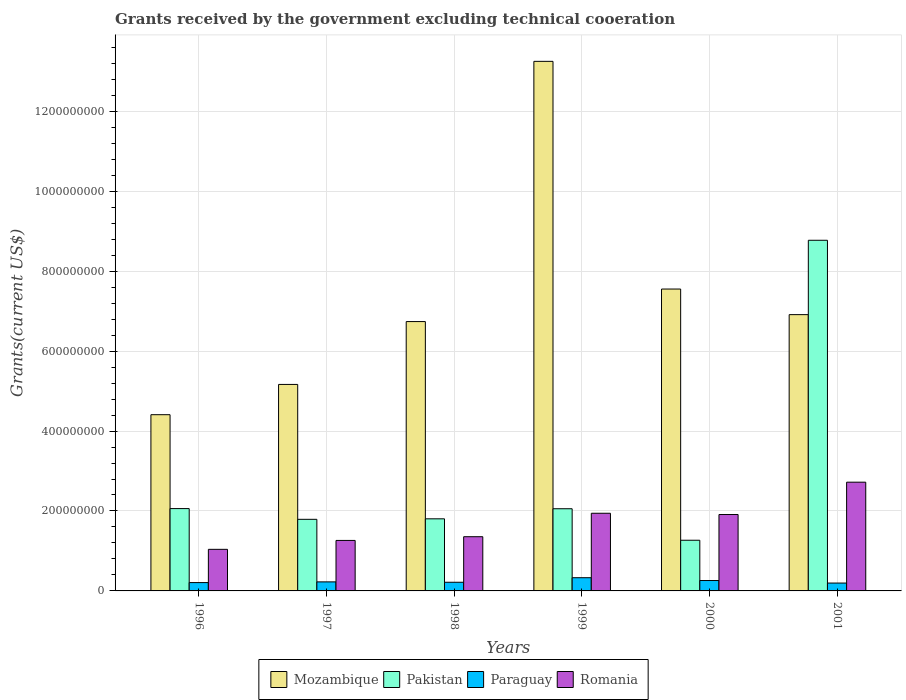How many groups of bars are there?
Provide a short and direct response. 6. How many bars are there on the 3rd tick from the left?
Give a very brief answer. 4. How many bars are there on the 3rd tick from the right?
Make the answer very short. 4. What is the total grants received by the government in Paraguay in 2001?
Offer a very short reply. 1.97e+07. Across all years, what is the maximum total grants received by the government in Mozambique?
Your answer should be very brief. 1.32e+09. Across all years, what is the minimum total grants received by the government in Pakistan?
Make the answer very short. 1.27e+08. In which year was the total grants received by the government in Mozambique minimum?
Your answer should be very brief. 1996. What is the total total grants received by the government in Mozambique in the graph?
Keep it short and to the point. 4.40e+09. What is the difference between the total grants received by the government in Mozambique in 1997 and that in 2001?
Offer a very short reply. -1.75e+08. What is the difference between the total grants received by the government in Paraguay in 2000 and the total grants received by the government in Pakistan in 2001?
Offer a terse response. -8.51e+08. What is the average total grants received by the government in Mozambique per year?
Provide a succinct answer. 7.34e+08. In the year 1998, what is the difference between the total grants received by the government in Romania and total grants received by the government in Mozambique?
Your answer should be compact. -5.38e+08. In how many years, is the total grants received by the government in Pakistan greater than 800000000 US$?
Provide a succinct answer. 1. What is the ratio of the total grants received by the government in Paraguay in 1996 to that in 1999?
Offer a terse response. 0.63. Is the total grants received by the government in Romania in 1997 less than that in 2000?
Provide a short and direct response. Yes. Is the difference between the total grants received by the government in Romania in 1996 and 1998 greater than the difference between the total grants received by the government in Mozambique in 1996 and 1998?
Provide a short and direct response. Yes. What is the difference between the highest and the second highest total grants received by the government in Mozambique?
Ensure brevity in your answer.  5.70e+08. What is the difference between the highest and the lowest total grants received by the government in Mozambique?
Offer a very short reply. 8.84e+08. Is it the case that in every year, the sum of the total grants received by the government in Pakistan and total grants received by the government in Mozambique is greater than the sum of total grants received by the government in Paraguay and total grants received by the government in Romania?
Make the answer very short. No. What does the 3rd bar from the left in 1999 represents?
Ensure brevity in your answer.  Paraguay. What does the 3rd bar from the right in 2000 represents?
Keep it short and to the point. Pakistan. Are all the bars in the graph horizontal?
Provide a short and direct response. No. Does the graph contain any zero values?
Give a very brief answer. No. Does the graph contain grids?
Provide a succinct answer. Yes. Where does the legend appear in the graph?
Your answer should be very brief. Bottom center. What is the title of the graph?
Your answer should be compact. Grants received by the government excluding technical cooeration. Does "Korea (Republic)" appear as one of the legend labels in the graph?
Your answer should be very brief. No. What is the label or title of the Y-axis?
Offer a very short reply. Grants(current US$). What is the Grants(current US$) in Mozambique in 1996?
Make the answer very short. 4.41e+08. What is the Grants(current US$) of Pakistan in 1996?
Give a very brief answer. 2.06e+08. What is the Grants(current US$) of Paraguay in 1996?
Keep it short and to the point. 2.08e+07. What is the Grants(current US$) in Romania in 1996?
Give a very brief answer. 1.04e+08. What is the Grants(current US$) of Mozambique in 1997?
Keep it short and to the point. 5.17e+08. What is the Grants(current US$) of Pakistan in 1997?
Provide a succinct answer. 1.79e+08. What is the Grants(current US$) of Paraguay in 1997?
Make the answer very short. 2.26e+07. What is the Grants(current US$) in Romania in 1997?
Provide a short and direct response. 1.26e+08. What is the Grants(current US$) of Mozambique in 1998?
Keep it short and to the point. 6.74e+08. What is the Grants(current US$) in Pakistan in 1998?
Provide a short and direct response. 1.80e+08. What is the Grants(current US$) in Paraguay in 1998?
Offer a terse response. 2.17e+07. What is the Grants(current US$) in Romania in 1998?
Provide a short and direct response. 1.36e+08. What is the Grants(current US$) of Mozambique in 1999?
Your answer should be very brief. 1.32e+09. What is the Grants(current US$) in Pakistan in 1999?
Provide a short and direct response. 2.06e+08. What is the Grants(current US$) of Paraguay in 1999?
Your response must be concise. 3.30e+07. What is the Grants(current US$) of Romania in 1999?
Give a very brief answer. 1.94e+08. What is the Grants(current US$) in Mozambique in 2000?
Keep it short and to the point. 7.55e+08. What is the Grants(current US$) of Pakistan in 2000?
Your answer should be compact. 1.27e+08. What is the Grants(current US$) of Paraguay in 2000?
Provide a short and direct response. 2.60e+07. What is the Grants(current US$) of Romania in 2000?
Your answer should be very brief. 1.91e+08. What is the Grants(current US$) of Mozambique in 2001?
Ensure brevity in your answer.  6.91e+08. What is the Grants(current US$) in Pakistan in 2001?
Offer a very short reply. 8.77e+08. What is the Grants(current US$) of Paraguay in 2001?
Give a very brief answer. 1.97e+07. What is the Grants(current US$) in Romania in 2001?
Give a very brief answer. 2.72e+08. Across all years, what is the maximum Grants(current US$) in Mozambique?
Your response must be concise. 1.32e+09. Across all years, what is the maximum Grants(current US$) of Pakistan?
Your answer should be compact. 8.77e+08. Across all years, what is the maximum Grants(current US$) in Paraguay?
Offer a terse response. 3.30e+07. Across all years, what is the maximum Grants(current US$) in Romania?
Your answer should be compact. 2.72e+08. Across all years, what is the minimum Grants(current US$) of Mozambique?
Provide a short and direct response. 4.41e+08. Across all years, what is the minimum Grants(current US$) in Pakistan?
Offer a very short reply. 1.27e+08. Across all years, what is the minimum Grants(current US$) in Paraguay?
Provide a succinct answer. 1.97e+07. Across all years, what is the minimum Grants(current US$) in Romania?
Make the answer very short. 1.04e+08. What is the total Grants(current US$) of Mozambique in the graph?
Your answer should be very brief. 4.40e+09. What is the total Grants(current US$) in Pakistan in the graph?
Ensure brevity in your answer.  1.78e+09. What is the total Grants(current US$) of Paraguay in the graph?
Your response must be concise. 1.44e+08. What is the total Grants(current US$) in Romania in the graph?
Make the answer very short. 1.02e+09. What is the difference between the Grants(current US$) of Mozambique in 1996 and that in 1997?
Offer a terse response. -7.58e+07. What is the difference between the Grants(current US$) of Pakistan in 1996 and that in 1997?
Provide a succinct answer. 2.69e+07. What is the difference between the Grants(current US$) in Paraguay in 1996 and that in 1997?
Your response must be concise. -1.77e+06. What is the difference between the Grants(current US$) in Romania in 1996 and that in 1997?
Your response must be concise. -2.23e+07. What is the difference between the Grants(current US$) in Mozambique in 1996 and that in 1998?
Your answer should be compact. -2.33e+08. What is the difference between the Grants(current US$) in Pakistan in 1996 and that in 1998?
Provide a succinct answer. 2.56e+07. What is the difference between the Grants(current US$) of Paraguay in 1996 and that in 1998?
Ensure brevity in your answer.  -8.20e+05. What is the difference between the Grants(current US$) in Romania in 1996 and that in 1998?
Your response must be concise. -3.16e+07. What is the difference between the Grants(current US$) in Mozambique in 1996 and that in 1999?
Ensure brevity in your answer.  -8.84e+08. What is the difference between the Grants(current US$) of Paraguay in 1996 and that in 1999?
Keep it short and to the point. -1.22e+07. What is the difference between the Grants(current US$) in Romania in 1996 and that in 1999?
Your response must be concise. -9.02e+07. What is the difference between the Grants(current US$) of Mozambique in 1996 and that in 2000?
Your answer should be compact. -3.14e+08. What is the difference between the Grants(current US$) in Pakistan in 1996 and that in 2000?
Ensure brevity in your answer.  7.92e+07. What is the difference between the Grants(current US$) in Paraguay in 1996 and that in 2000?
Give a very brief answer. -5.18e+06. What is the difference between the Grants(current US$) in Romania in 1996 and that in 2000?
Provide a short and direct response. -8.71e+07. What is the difference between the Grants(current US$) in Mozambique in 1996 and that in 2001?
Your answer should be very brief. -2.50e+08. What is the difference between the Grants(current US$) of Pakistan in 1996 and that in 2001?
Give a very brief answer. -6.71e+08. What is the difference between the Grants(current US$) in Paraguay in 1996 and that in 2001?
Offer a terse response. 1.16e+06. What is the difference between the Grants(current US$) in Romania in 1996 and that in 2001?
Your answer should be very brief. -1.68e+08. What is the difference between the Grants(current US$) of Mozambique in 1997 and that in 1998?
Offer a terse response. -1.57e+08. What is the difference between the Grants(current US$) of Pakistan in 1997 and that in 1998?
Provide a short and direct response. -1.25e+06. What is the difference between the Grants(current US$) of Paraguay in 1997 and that in 1998?
Make the answer very short. 9.50e+05. What is the difference between the Grants(current US$) in Romania in 1997 and that in 1998?
Give a very brief answer. -9.32e+06. What is the difference between the Grants(current US$) of Mozambique in 1997 and that in 1999?
Make the answer very short. -8.08e+08. What is the difference between the Grants(current US$) of Pakistan in 1997 and that in 1999?
Your answer should be very brief. -2.65e+07. What is the difference between the Grants(current US$) of Paraguay in 1997 and that in 1999?
Offer a very short reply. -1.04e+07. What is the difference between the Grants(current US$) of Romania in 1997 and that in 1999?
Your response must be concise. -6.80e+07. What is the difference between the Grants(current US$) of Mozambique in 1997 and that in 2000?
Make the answer very short. -2.39e+08. What is the difference between the Grants(current US$) in Pakistan in 1997 and that in 2000?
Your answer should be compact. 5.23e+07. What is the difference between the Grants(current US$) in Paraguay in 1997 and that in 2000?
Offer a terse response. -3.41e+06. What is the difference between the Grants(current US$) in Romania in 1997 and that in 2000?
Offer a very short reply. -6.48e+07. What is the difference between the Grants(current US$) of Mozambique in 1997 and that in 2001?
Offer a very short reply. -1.75e+08. What is the difference between the Grants(current US$) in Pakistan in 1997 and that in 2001?
Make the answer very short. -6.98e+08. What is the difference between the Grants(current US$) of Paraguay in 1997 and that in 2001?
Offer a terse response. 2.93e+06. What is the difference between the Grants(current US$) in Romania in 1997 and that in 2001?
Ensure brevity in your answer.  -1.46e+08. What is the difference between the Grants(current US$) of Mozambique in 1998 and that in 1999?
Provide a succinct answer. -6.51e+08. What is the difference between the Grants(current US$) of Pakistan in 1998 and that in 1999?
Provide a succinct answer. -2.52e+07. What is the difference between the Grants(current US$) in Paraguay in 1998 and that in 1999?
Make the answer very short. -1.14e+07. What is the difference between the Grants(current US$) in Romania in 1998 and that in 1999?
Give a very brief answer. -5.87e+07. What is the difference between the Grants(current US$) of Mozambique in 1998 and that in 2000?
Provide a short and direct response. -8.14e+07. What is the difference between the Grants(current US$) in Pakistan in 1998 and that in 2000?
Make the answer very short. 5.36e+07. What is the difference between the Grants(current US$) in Paraguay in 1998 and that in 2000?
Your answer should be very brief. -4.36e+06. What is the difference between the Grants(current US$) of Romania in 1998 and that in 2000?
Offer a very short reply. -5.55e+07. What is the difference between the Grants(current US$) of Mozambique in 1998 and that in 2001?
Make the answer very short. -1.74e+07. What is the difference between the Grants(current US$) of Pakistan in 1998 and that in 2001?
Your answer should be very brief. -6.97e+08. What is the difference between the Grants(current US$) in Paraguay in 1998 and that in 2001?
Your answer should be very brief. 1.98e+06. What is the difference between the Grants(current US$) of Romania in 1998 and that in 2001?
Make the answer very short. -1.36e+08. What is the difference between the Grants(current US$) in Mozambique in 1999 and that in 2000?
Ensure brevity in your answer.  5.70e+08. What is the difference between the Grants(current US$) of Pakistan in 1999 and that in 2000?
Your answer should be very brief. 7.88e+07. What is the difference between the Grants(current US$) in Paraguay in 1999 and that in 2000?
Provide a succinct answer. 7.03e+06. What is the difference between the Grants(current US$) of Romania in 1999 and that in 2000?
Keep it short and to the point. 3.17e+06. What is the difference between the Grants(current US$) in Mozambique in 1999 and that in 2001?
Your answer should be very brief. 6.34e+08. What is the difference between the Grants(current US$) in Pakistan in 1999 and that in 2001?
Make the answer very short. -6.72e+08. What is the difference between the Grants(current US$) in Paraguay in 1999 and that in 2001?
Offer a terse response. 1.34e+07. What is the difference between the Grants(current US$) in Romania in 1999 and that in 2001?
Keep it short and to the point. -7.78e+07. What is the difference between the Grants(current US$) in Mozambique in 2000 and that in 2001?
Ensure brevity in your answer.  6.40e+07. What is the difference between the Grants(current US$) of Pakistan in 2000 and that in 2001?
Provide a succinct answer. -7.51e+08. What is the difference between the Grants(current US$) in Paraguay in 2000 and that in 2001?
Ensure brevity in your answer.  6.34e+06. What is the difference between the Grants(current US$) of Romania in 2000 and that in 2001?
Offer a very short reply. -8.10e+07. What is the difference between the Grants(current US$) in Mozambique in 1996 and the Grants(current US$) in Pakistan in 1997?
Your response must be concise. 2.62e+08. What is the difference between the Grants(current US$) of Mozambique in 1996 and the Grants(current US$) of Paraguay in 1997?
Offer a terse response. 4.18e+08. What is the difference between the Grants(current US$) in Mozambique in 1996 and the Grants(current US$) in Romania in 1997?
Ensure brevity in your answer.  3.15e+08. What is the difference between the Grants(current US$) of Pakistan in 1996 and the Grants(current US$) of Paraguay in 1997?
Keep it short and to the point. 1.83e+08. What is the difference between the Grants(current US$) in Pakistan in 1996 and the Grants(current US$) in Romania in 1997?
Your answer should be very brief. 7.97e+07. What is the difference between the Grants(current US$) of Paraguay in 1996 and the Grants(current US$) of Romania in 1997?
Your answer should be compact. -1.05e+08. What is the difference between the Grants(current US$) in Mozambique in 1996 and the Grants(current US$) in Pakistan in 1998?
Make the answer very short. 2.61e+08. What is the difference between the Grants(current US$) of Mozambique in 1996 and the Grants(current US$) of Paraguay in 1998?
Provide a short and direct response. 4.19e+08. What is the difference between the Grants(current US$) in Mozambique in 1996 and the Grants(current US$) in Romania in 1998?
Provide a succinct answer. 3.05e+08. What is the difference between the Grants(current US$) in Pakistan in 1996 and the Grants(current US$) in Paraguay in 1998?
Your answer should be compact. 1.84e+08. What is the difference between the Grants(current US$) of Pakistan in 1996 and the Grants(current US$) of Romania in 1998?
Give a very brief answer. 7.04e+07. What is the difference between the Grants(current US$) of Paraguay in 1996 and the Grants(current US$) of Romania in 1998?
Your answer should be very brief. -1.15e+08. What is the difference between the Grants(current US$) of Mozambique in 1996 and the Grants(current US$) of Pakistan in 1999?
Offer a terse response. 2.35e+08. What is the difference between the Grants(current US$) in Mozambique in 1996 and the Grants(current US$) in Paraguay in 1999?
Your answer should be very brief. 4.08e+08. What is the difference between the Grants(current US$) of Mozambique in 1996 and the Grants(current US$) of Romania in 1999?
Keep it short and to the point. 2.47e+08. What is the difference between the Grants(current US$) in Pakistan in 1996 and the Grants(current US$) in Paraguay in 1999?
Ensure brevity in your answer.  1.73e+08. What is the difference between the Grants(current US$) of Pakistan in 1996 and the Grants(current US$) of Romania in 1999?
Keep it short and to the point. 1.17e+07. What is the difference between the Grants(current US$) in Paraguay in 1996 and the Grants(current US$) in Romania in 1999?
Your response must be concise. -1.73e+08. What is the difference between the Grants(current US$) in Mozambique in 1996 and the Grants(current US$) in Pakistan in 2000?
Ensure brevity in your answer.  3.14e+08. What is the difference between the Grants(current US$) in Mozambique in 1996 and the Grants(current US$) in Paraguay in 2000?
Provide a short and direct response. 4.15e+08. What is the difference between the Grants(current US$) in Mozambique in 1996 and the Grants(current US$) in Romania in 2000?
Provide a succinct answer. 2.50e+08. What is the difference between the Grants(current US$) of Pakistan in 1996 and the Grants(current US$) of Paraguay in 2000?
Provide a short and direct response. 1.80e+08. What is the difference between the Grants(current US$) of Pakistan in 1996 and the Grants(current US$) of Romania in 2000?
Ensure brevity in your answer.  1.49e+07. What is the difference between the Grants(current US$) of Paraguay in 1996 and the Grants(current US$) of Romania in 2000?
Offer a terse response. -1.70e+08. What is the difference between the Grants(current US$) of Mozambique in 1996 and the Grants(current US$) of Pakistan in 2001?
Your response must be concise. -4.36e+08. What is the difference between the Grants(current US$) of Mozambique in 1996 and the Grants(current US$) of Paraguay in 2001?
Give a very brief answer. 4.21e+08. What is the difference between the Grants(current US$) of Mozambique in 1996 and the Grants(current US$) of Romania in 2001?
Offer a terse response. 1.69e+08. What is the difference between the Grants(current US$) of Pakistan in 1996 and the Grants(current US$) of Paraguay in 2001?
Offer a terse response. 1.86e+08. What is the difference between the Grants(current US$) in Pakistan in 1996 and the Grants(current US$) in Romania in 2001?
Provide a short and direct response. -6.61e+07. What is the difference between the Grants(current US$) of Paraguay in 1996 and the Grants(current US$) of Romania in 2001?
Keep it short and to the point. -2.51e+08. What is the difference between the Grants(current US$) of Mozambique in 1997 and the Grants(current US$) of Pakistan in 1998?
Your response must be concise. 3.36e+08. What is the difference between the Grants(current US$) in Mozambique in 1997 and the Grants(current US$) in Paraguay in 1998?
Keep it short and to the point. 4.95e+08. What is the difference between the Grants(current US$) in Mozambique in 1997 and the Grants(current US$) in Romania in 1998?
Keep it short and to the point. 3.81e+08. What is the difference between the Grants(current US$) of Pakistan in 1997 and the Grants(current US$) of Paraguay in 1998?
Offer a terse response. 1.57e+08. What is the difference between the Grants(current US$) in Pakistan in 1997 and the Grants(current US$) in Romania in 1998?
Provide a short and direct response. 4.35e+07. What is the difference between the Grants(current US$) of Paraguay in 1997 and the Grants(current US$) of Romania in 1998?
Give a very brief answer. -1.13e+08. What is the difference between the Grants(current US$) of Mozambique in 1997 and the Grants(current US$) of Pakistan in 1999?
Give a very brief answer. 3.11e+08. What is the difference between the Grants(current US$) in Mozambique in 1997 and the Grants(current US$) in Paraguay in 1999?
Provide a succinct answer. 4.84e+08. What is the difference between the Grants(current US$) in Mozambique in 1997 and the Grants(current US$) in Romania in 1999?
Give a very brief answer. 3.22e+08. What is the difference between the Grants(current US$) in Pakistan in 1997 and the Grants(current US$) in Paraguay in 1999?
Keep it short and to the point. 1.46e+08. What is the difference between the Grants(current US$) in Pakistan in 1997 and the Grants(current US$) in Romania in 1999?
Your answer should be very brief. -1.52e+07. What is the difference between the Grants(current US$) in Paraguay in 1997 and the Grants(current US$) in Romania in 1999?
Your answer should be compact. -1.72e+08. What is the difference between the Grants(current US$) in Mozambique in 1997 and the Grants(current US$) in Pakistan in 2000?
Ensure brevity in your answer.  3.90e+08. What is the difference between the Grants(current US$) of Mozambique in 1997 and the Grants(current US$) of Paraguay in 2000?
Offer a terse response. 4.91e+08. What is the difference between the Grants(current US$) of Mozambique in 1997 and the Grants(current US$) of Romania in 2000?
Your answer should be very brief. 3.26e+08. What is the difference between the Grants(current US$) of Pakistan in 1997 and the Grants(current US$) of Paraguay in 2000?
Make the answer very short. 1.53e+08. What is the difference between the Grants(current US$) of Pakistan in 1997 and the Grants(current US$) of Romania in 2000?
Offer a terse response. -1.20e+07. What is the difference between the Grants(current US$) in Paraguay in 1997 and the Grants(current US$) in Romania in 2000?
Provide a succinct answer. -1.69e+08. What is the difference between the Grants(current US$) of Mozambique in 1997 and the Grants(current US$) of Pakistan in 2001?
Your response must be concise. -3.61e+08. What is the difference between the Grants(current US$) in Mozambique in 1997 and the Grants(current US$) in Paraguay in 2001?
Your response must be concise. 4.97e+08. What is the difference between the Grants(current US$) of Mozambique in 1997 and the Grants(current US$) of Romania in 2001?
Your answer should be compact. 2.45e+08. What is the difference between the Grants(current US$) of Pakistan in 1997 and the Grants(current US$) of Paraguay in 2001?
Your answer should be very brief. 1.59e+08. What is the difference between the Grants(current US$) in Pakistan in 1997 and the Grants(current US$) in Romania in 2001?
Offer a very short reply. -9.30e+07. What is the difference between the Grants(current US$) in Paraguay in 1997 and the Grants(current US$) in Romania in 2001?
Provide a short and direct response. -2.49e+08. What is the difference between the Grants(current US$) of Mozambique in 1998 and the Grants(current US$) of Pakistan in 1999?
Offer a terse response. 4.68e+08. What is the difference between the Grants(current US$) of Mozambique in 1998 and the Grants(current US$) of Paraguay in 1999?
Keep it short and to the point. 6.41e+08. What is the difference between the Grants(current US$) in Mozambique in 1998 and the Grants(current US$) in Romania in 1999?
Ensure brevity in your answer.  4.80e+08. What is the difference between the Grants(current US$) of Pakistan in 1998 and the Grants(current US$) of Paraguay in 1999?
Provide a short and direct response. 1.47e+08. What is the difference between the Grants(current US$) in Pakistan in 1998 and the Grants(current US$) in Romania in 1999?
Offer a terse response. -1.39e+07. What is the difference between the Grants(current US$) of Paraguay in 1998 and the Grants(current US$) of Romania in 1999?
Keep it short and to the point. -1.73e+08. What is the difference between the Grants(current US$) of Mozambique in 1998 and the Grants(current US$) of Pakistan in 2000?
Your answer should be very brief. 5.47e+08. What is the difference between the Grants(current US$) of Mozambique in 1998 and the Grants(current US$) of Paraguay in 2000?
Provide a short and direct response. 6.48e+08. What is the difference between the Grants(current US$) of Mozambique in 1998 and the Grants(current US$) of Romania in 2000?
Keep it short and to the point. 4.83e+08. What is the difference between the Grants(current US$) in Pakistan in 1998 and the Grants(current US$) in Paraguay in 2000?
Provide a short and direct response. 1.54e+08. What is the difference between the Grants(current US$) of Pakistan in 1998 and the Grants(current US$) of Romania in 2000?
Offer a terse response. -1.08e+07. What is the difference between the Grants(current US$) in Paraguay in 1998 and the Grants(current US$) in Romania in 2000?
Offer a very short reply. -1.69e+08. What is the difference between the Grants(current US$) in Mozambique in 1998 and the Grants(current US$) in Pakistan in 2001?
Your response must be concise. -2.03e+08. What is the difference between the Grants(current US$) of Mozambique in 1998 and the Grants(current US$) of Paraguay in 2001?
Offer a terse response. 6.54e+08. What is the difference between the Grants(current US$) in Mozambique in 1998 and the Grants(current US$) in Romania in 2001?
Your answer should be compact. 4.02e+08. What is the difference between the Grants(current US$) of Pakistan in 1998 and the Grants(current US$) of Paraguay in 2001?
Your answer should be compact. 1.61e+08. What is the difference between the Grants(current US$) of Pakistan in 1998 and the Grants(current US$) of Romania in 2001?
Offer a very short reply. -9.17e+07. What is the difference between the Grants(current US$) in Paraguay in 1998 and the Grants(current US$) in Romania in 2001?
Provide a succinct answer. -2.50e+08. What is the difference between the Grants(current US$) of Mozambique in 1999 and the Grants(current US$) of Pakistan in 2000?
Keep it short and to the point. 1.20e+09. What is the difference between the Grants(current US$) in Mozambique in 1999 and the Grants(current US$) in Paraguay in 2000?
Make the answer very short. 1.30e+09. What is the difference between the Grants(current US$) of Mozambique in 1999 and the Grants(current US$) of Romania in 2000?
Give a very brief answer. 1.13e+09. What is the difference between the Grants(current US$) in Pakistan in 1999 and the Grants(current US$) in Paraguay in 2000?
Keep it short and to the point. 1.80e+08. What is the difference between the Grants(current US$) in Pakistan in 1999 and the Grants(current US$) in Romania in 2000?
Provide a short and direct response. 1.45e+07. What is the difference between the Grants(current US$) in Paraguay in 1999 and the Grants(current US$) in Romania in 2000?
Your response must be concise. -1.58e+08. What is the difference between the Grants(current US$) of Mozambique in 1999 and the Grants(current US$) of Pakistan in 2001?
Offer a very short reply. 4.48e+08. What is the difference between the Grants(current US$) of Mozambique in 1999 and the Grants(current US$) of Paraguay in 2001?
Your answer should be compact. 1.31e+09. What is the difference between the Grants(current US$) in Mozambique in 1999 and the Grants(current US$) in Romania in 2001?
Give a very brief answer. 1.05e+09. What is the difference between the Grants(current US$) of Pakistan in 1999 and the Grants(current US$) of Paraguay in 2001?
Your answer should be compact. 1.86e+08. What is the difference between the Grants(current US$) of Pakistan in 1999 and the Grants(current US$) of Romania in 2001?
Offer a terse response. -6.65e+07. What is the difference between the Grants(current US$) of Paraguay in 1999 and the Grants(current US$) of Romania in 2001?
Keep it short and to the point. -2.39e+08. What is the difference between the Grants(current US$) of Mozambique in 2000 and the Grants(current US$) of Pakistan in 2001?
Your answer should be very brief. -1.22e+08. What is the difference between the Grants(current US$) in Mozambique in 2000 and the Grants(current US$) in Paraguay in 2001?
Your response must be concise. 7.36e+08. What is the difference between the Grants(current US$) in Mozambique in 2000 and the Grants(current US$) in Romania in 2001?
Ensure brevity in your answer.  4.83e+08. What is the difference between the Grants(current US$) of Pakistan in 2000 and the Grants(current US$) of Paraguay in 2001?
Offer a terse response. 1.07e+08. What is the difference between the Grants(current US$) of Pakistan in 2000 and the Grants(current US$) of Romania in 2001?
Provide a succinct answer. -1.45e+08. What is the difference between the Grants(current US$) of Paraguay in 2000 and the Grants(current US$) of Romania in 2001?
Your answer should be very brief. -2.46e+08. What is the average Grants(current US$) of Mozambique per year?
Your answer should be compact. 7.34e+08. What is the average Grants(current US$) in Pakistan per year?
Keep it short and to the point. 2.96e+08. What is the average Grants(current US$) in Paraguay per year?
Your response must be concise. 2.40e+07. What is the average Grants(current US$) in Romania per year?
Provide a succinct answer. 1.71e+08. In the year 1996, what is the difference between the Grants(current US$) in Mozambique and Grants(current US$) in Pakistan?
Provide a succinct answer. 2.35e+08. In the year 1996, what is the difference between the Grants(current US$) in Mozambique and Grants(current US$) in Paraguay?
Your response must be concise. 4.20e+08. In the year 1996, what is the difference between the Grants(current US$) of Mozambique and Grants(current US$) of Romania?
Offer a terse response. 3.37e+08. In the year 1996, what is the difference between the Grants(current US$) in Pakistan and Grants(current US$) in Paraguay?
Ensure brevity in your answer.  1.85e+08. In the year 1996, what is the difference between the Grants(current US$) in Pakistan and Grants(current US$) in Romania?
Offer a very short reply. 1.02e+08. In the year 1996, what is the difference between the Grants(current US$) of Paraguay and Grants(current US$) of Romania?
Keep it short and to the point. -8.32e+07. In the year 1997, what is the difference between the Grants(current US$) in Mozambique and Grants(current US$) in Pakistan?
Your answer should be very brief. 3.38e+08. In the year 1997, what is the difference between the Grants(current US$) in Mozambique and Grants(current US$) in Paraguay?
Offer a terse response. 4.94e+08. In the year 1997, what is the difference between the Grants(current US$) of Mozambique and Grants(current US$) of Romania?
Offer a terse response. 3.90e+08. In the year 1997, what is the difference between the Grants(current US$) in Pakistan and Grants(current US$) in Paraguay?
Offer a terse response. 1.57e+08. In the year 1997, what is the difference between the Grants(current US$) in Pakistan and Grants(current US$) in Romania?
Offer a very short reply. 5.28e+07. In the year 1997, what is the difference between the Grants(current US$) of Paraguay and Grants(current US$) of Romania?
Make the answer very short. -1.04e+08. In the year 1998, what is the difference between the Grants(current US$) in Mozambique and Grants(current US$) in Pakistan?
Ensure brevity in your answer.  4.94e+08. In the year 1998, what is the difference between the Grants(current US$) of Mozambique and Grants(current US$) of Paraguay?
Offer a very short reply. 6.52e+08. In the year 1998, what is the difference between the Grants(current US$) in Mozambique and Grants(current US$) in Romania?
Keep it short and to the point. 5.38e+08. In the year 1998, what is the difference between the Grants(current US$) of Pakistan and Grants(current US$) of Paraguay?
Provide a succinct answer. 1.59e+08. In the year 1998, what is the difference between the Grants(current US$) in Pakistan and Grants(current US$) in Romania?
Keep it short and to the point. 4.47e+07. In the year 1998, what is the difference between the Grants(current US$) of Paraguay and Grants(current US$) of Romania?
Provide a short and direct response. -1.14e+08. In the year 1999, what is the difference between the Grants(current US$) of Mozambique and Grants(current US$) of Pakistan?
Your response must be concise. 1.12e+09. In the year 1999, what is the difference between the Grants(current US$) of Mozambique and Grants(current US$) of Paraguay?
Ensure brevity in your answer.  1.29e+09. In the year 1999, what is the difference between the Grants(current US$) in Mozambique and Grants(current US$) in Romania?
Provide a succinct answer. 1.13e+09. In the year 1999, what is the difference between the Grants(current US$) of Pakistan and Grants(current US$) of Paraguay?
Keep it short and to the point. 1.73e+08. In the year 1999, what is the difference between the Grants(current US$) in Pakistan and Grants(current US$) in Romania?
Your answer should be very brief. 1.13e+07. In the year 1999, what is the difference between the Grants(current US$) of Paraguay and Grants(current US$) of Romania?
Offer a terse response. -1.61e+08. In the year 2000, what is the difference between the Grants(current US$) of Mozambique and Grants(current US$) of Pakistan?
Ensure brevity in your answer.  6.29e+08. In the year 2000, what is the difference between the Grants(current US$) in Mozambique and Grants(current US$) in Paraguay?
Keep it short and to the point. 7.29e+08. In the year 2000, what is the difference between the Grants(current US$) in Mozambique and Grants(current US$) in Romania?
Offer a very short reply. 5.64e+08. In the year 2000, what is the difference between the Grants(current US$) of Pakistan and Grants(current US$) of Paraguay?
Offer a terse response. 1.01e+08. In the year 2000, what is the difference between the Grants(current US$) of Pakistan and Grants(current US$) of Romania?
Your answer should be very brief. -6.43e+07. In the year 2000, what is the difference between the Grants(current US$) of Paraguay and Grants(current US$) of Romania?
Ensure brevity in your answer.  -1.65e+08. In the year 2001, what is the difference between the Grants(current US$) of Mozambique and Grants(current US$) of Pakistan?
Give a very brief answer. -1.86e+08. In the year 2001, what is the difference between the Grants(current US$) of Mozambique and Grants(current US$) of Paraguay?
Offer a terse response. 6.72e+08. In the year 2001, what is the difference between the Grants(current US$) of Mozambique and Grants(current US$) of Romania?
Make the answer very short. 4.19e+08. In the year 2001, what is the difference between the Grants(current US$) in Pakistan and Grants(current US$) in Paraguay?
Make the answer very short. 8.58e+08. In the year 2001, what is the difference between the Grants(current US$) of Pakistan and Grants(current US$) of Romania?
Provide a short and direct response. 6.05e+08. In the year 2001, what is the difference between the Grants(current US$) of Paraguay and Grants(current US$) of Romania?
Keep it short and to the point. -2.52e+08. What is the ratio of the Grants(current US$) in Mozambique in 1996 to that in 1997?
Offer a very short reply. 0.85. What is the ratio of the Grants(current US$) of Pakistan in 1996 to that in 1997?
Provide a short and direct response. 1.15. What is the ratio of the Grants(current US$) of Paraguay in 1996 to that in 1997?
Your answer should be very brief. 0.92. What is the ratio of the Grants(current US$) of Romania in 1996 to that in 1997?
Give a very brief answer. 0.82. What is the ratio of the Grants(current US$) of Mozambique in 1996 to that in 1998?
Offer a very short reply. 0.65. What is the ratio of the Grants(current US$) in Pakistan in 1996 to that in 1998?
Give a very brief answer. 1.14. What is the ratio of the Grants(current US$) of Paraguay in 1996 to that in 1998?
Offer a terse response. 0.96. What is the ratio of the Grants(current US$) in Romania in 1996 to that in 1998?
Give a very brief answer. 0.77. What is the ratio of the Grants(current US$) in Mozambique in 1996 to that in 1999?
Your answer should be compact. 0.33. What is the ratio of the Grants(current US$) in Paraguay in 1996 to that in 1999?
Your response must be concise. 0.63. What is the ratio of the Grants(current US$) of Romania in 1996 to that in 1999?
Your answer should be very brief. 0.54. What is the ratio of the Grants(current US$) in Mozambique in 1996 to that in 2000?
Your answer should be compact. 0.58. What is the ratio of the Grants(current US$) in Pakistan in 1996 to that in 2000?
Provide a succinct answer. 1.62. What is the ratio of the Grants(current US$) in Paraguay in 1996 to that in 2000?
Give a very brief answer. 0.8. What is the ratio of the Grants(current US$) in Romania in 1996 to that in 2000?
Offer a terse response. 0.54. What is the ratio of the Grants(current US$) in Mozambique in 1996 to that in 2001?
Your answer should be very brief. 0.64. What is the ratio of the Grants(current US$) of Pakistan in 1996 to that in 2001?
Keep it short and to the point. 0.23. What is the ratio of the Grants(current US$) of Paraguay in 1996 to that in 2001?
Give a very brief answer. 1.06. What is the ratio of the Grants(current US$) of Romania in 1996 to that in 2001?
Your answer should be compact. 0.38. What is the ratio of the Grants(current US$) of Mozambique in 1997 to that in 1998?
Ensure brevity in your answer.  0.77. What is the ratio of the Grants(current US$) of Paraguay in 1997 to that in 1998?
Offer a very short reply. 1.04. What is the ratio of the Grants(current US$) of Romania in 1997 to that in 1998?
Offer a terse response. 0.93. What is the ratio of the Grants(current US$) in Mozambique in 1997 to that in 1999?
Provide a succinct answer. 0.39. What is the ratio of the Grants(current US$) in Pakistan in 1997 to that in 1999?
Your answer should be compact. 0.87. What is the ratio of the Grants(current US$) of Paraguay in 1997 to that in 1999?
Keep it short and to the point. 0.68. What is the ratio of the Grants(current US$) in Romania in 1997 to that in 1999?
Your answer should be very brief. 0.65. What is the ratio of the Grants(current US$) in Mozambique in 1997 to that in 2000?
Your answer should be very brief. 0.68. What is the ratio of the Grants(current US$) in Pakistan in 1997 to that in 2000?
Your answer should be compact. 1.41. What is the ratio of the Grants(current US$) in Paraguay in 1997 to that in 2000?
Provide a succinct answer. 0.87. What is the ratio of the Grants(current US$) of Romania in 1997 to that in 2000?
Ensure brevity in your answer.  0.66. What is the ratio of the Grants(current US$) in Mozambique in 1997 to that in 2001?
Your answer should be very brief. 0.75. What is the ratio of the Grants(current US$) of Pakistan in 1997 to that in 2001?
Offer a terse response. 0.2. What is the ratio of the Grants(current US$) in Paraguay in 1997 to that in 2001?
Offer a very short reply. 1.15. What is the ratio of the Grants(current US$) of Romania in 1997 to that in 2001?
Your answer should be very brief. 0.46. What is the ratio of the Grants(current US$) of Mozambique in 1998 to that in 1999?
Your response must be concise. 0.51. What is the ratio of the Grants(current US$) of Pakistan in 1998 to that in 1999?
Offer a very short reply. 0.88. What is the ratio of the Grants(current US$) of Paraguay in 1998 to that in 1999?
Keep it short and to the point. 0.66. What is the ratio of the Grants(current US$) in Romania in 1998 to that in 1999?
Provide a short and direct response. 0.7. What is the ratio of the Grants(current US$) of Mozambique in 1998 to that in 2000?
Ensure brevity in your answer.  0.89. What is the ratio of the Grants(current US$) of Pakistan in 1998 to that in 2000?
Your response must be concise. 1.42. What is the ratio of the Grants(current US$) of Paraguay in 1998 to that in 2000?
Offer a terse response. 0.83. What is the ratio of the Grants(current US$) of Romania in 1998 to that in 2000?
Offer a terse response. 0.71. What is the ratio of the Grants(current US$) in Mozambique in 1998 to that in 2001?
Provide a short and direct response. 0.97. What is the ratio of the Grants(current US$) of Pakistan in 1998 to that in 2001?
Ensure brevity in your answer.  0.21. What is the ratio of the Grants(current US$) of Paraguay in 1998 to that in 2001?
Your answer should be compact. 1.1. What is the ratio of the Grants(current US$) of Romania in 1998 to that in 2001?
Provide a succinct answer. 0.5. What is the ratio of the Grants(current US$) in Mozambique in 1999 to that in 2000?
Ensure brevity in your answer.  1.75. What is the ratio of the Grants(current US$) of Pakistan in 1999 to that in 2000?
Your answer should be very brief. 1.62. What is the ratio of the Grants(current US$) in Paraguay in 1999 to that in 2000?
Your response must be concise. 1.27. What is the ratio of the Grants(current US$) in Romania in 1999 to that in 2000?
Give a very brief answer. 1.02. What is the ratio of the Grants(current US$) of Mozambique in 1999 to that in 2001?
Offer a terse response. 1.92. What is the ratio of the Grants(current US$) of Pakistan in 1999 to that in 2001?
Keep it short and to the point. 0.23. What is the ratio of the Grants(current US$) in Paraguay in 1999 to that in 2001?
Make the answer very short. 1.68. What is the ratio of the Grants(current US$) in Romania in 1999 to that in 2001?
Your answer should be very brief. 0.71. What is the ratio of the Grants(current US$) in Mozambique in 2000 to that in 2001?
Offer a terse response. 1.09. What is the ratio of the Grants(current US$) of Pakistan in 2000 to that in 2001?
Your answer should be very brief. 0.14. What is the ratio of the Grants(current US$) of Paraguay in 2000 to that in 2001?
Ensure brevity in your answer.  1.32. What is the ratio of the Grants(current US$) in Romania in 2000 to that in 2001?
Your response must be concise. 0.7. What is the difference between the highest and the second highest Grants(current US$) of Mozambique?
Your answer should be compact. 5.70e+08. What is the difference between the highest and the second highest Grants(current US$) of Pakistan?
Offer a very short reply. 6.71e+08. What is the difference between the highest and the second highest Grants(current US$) in Paraguay?
Ensure brevity in your answer.  7.03e+06. What is the difference between the highest and the second highest Grants(current US$) of Romania?
Your answer should be compact. 7.78e+07. What is the difference between the highest and the lowest Grants(current US$) in Mozambique?
Your answer should be compact. 8.84e+08. What is the difference between the highest and the lowest Grants(current US$) in Pakistan?
Offer a very short reply. 7.51e+08. What is the difference between the highest and the lowest Grants(current US$) in Paraguay?
Provide a succinct answer. 1.34e+07. What is the difference between the highest and the lowest Grants(current US$) of Romania?
Offer a terse response. 1.68e+08. 